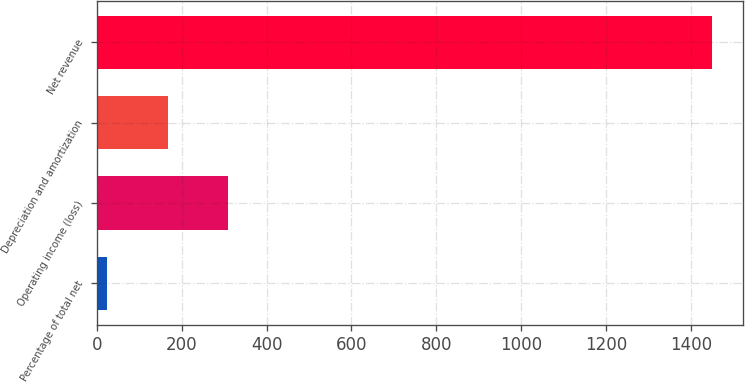Convert chart. <chart><loc_0><loc_0><loc_500><loc_500><bar_chart><fcel>Percentage of total net<fcel>Operating income (loss)<fcel>Depreciation and amortization<fcel>Net revenue<nl><fcel>25<fcel>310<fcel>167.5<fcel>1450<nl></chart> 